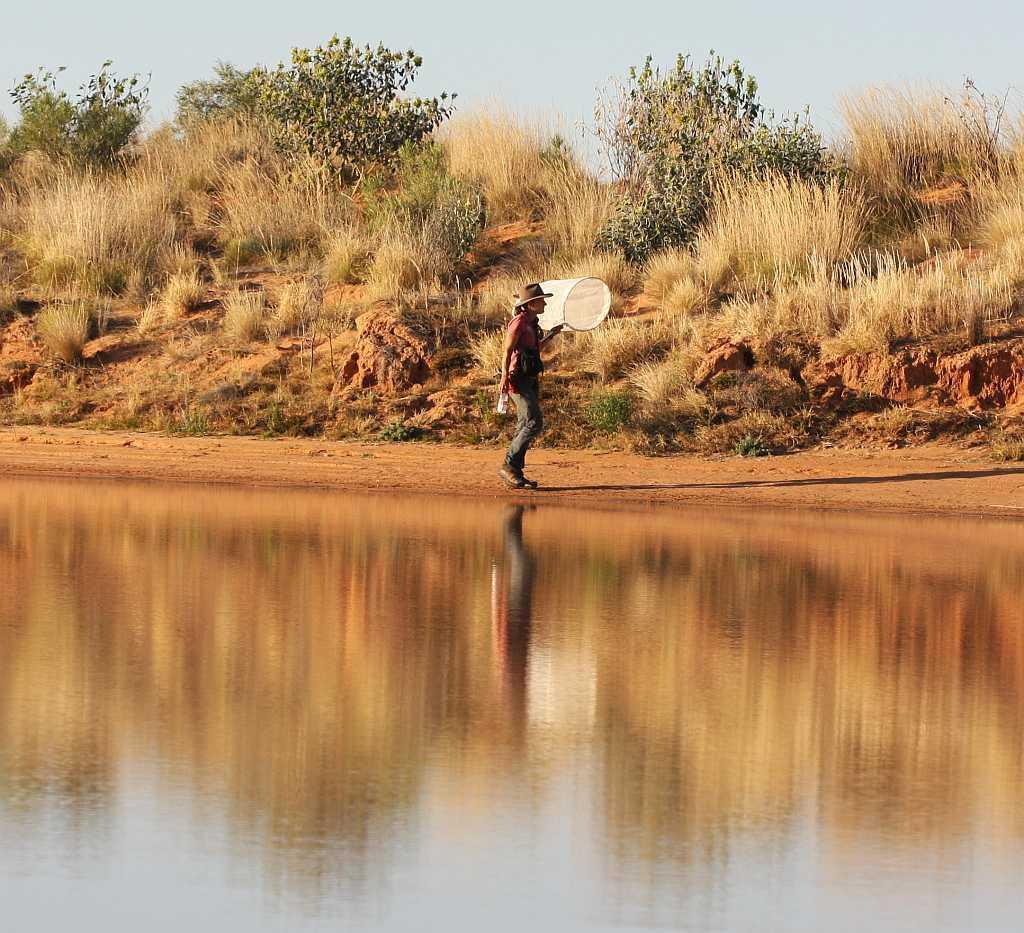Describe this image in one or two sentences. This is an outside view. At the bottom, I can see the water. In the middle of the image there is a person holding a net in the hand and walking on the ground towards the right side. In the background, I can see the grass and plants on the ground. At the top of the image I can see the sky. 